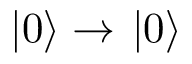Convert formula to latex. <formula><loc_0><loc_0><loc_500><loc_500>| 0 \right \rangle \rightarrow | 0 \right \rangle</formula> 